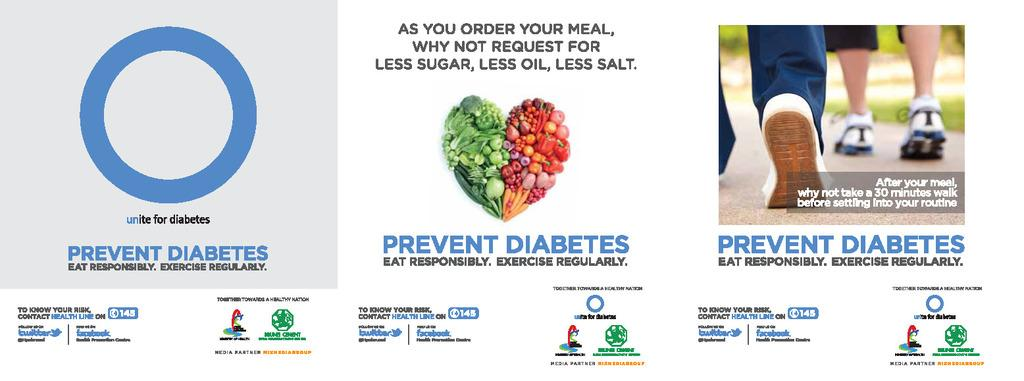What is present on the poster in the image? There is a poster in the image that contains text, images of persons' legs, fruits, vegetables, and logos. Can you describe the content of the poster in more detail? The poster contains text, images of persons' legs, fruits, vegetables, and logos. What type of images can be seen on the poster besides the legs? Images of fruits and vegetables can be seen on the poster. Are there any branding elements on the poster? Yes, there are logos on the poster. Can you see a glass of water in the image? There is no glass of water present in the image. Is there a garden visible in the image? There is no garden visible in the image. Can you find a toothbrush in the image? There is no toothbrush present in the image. 